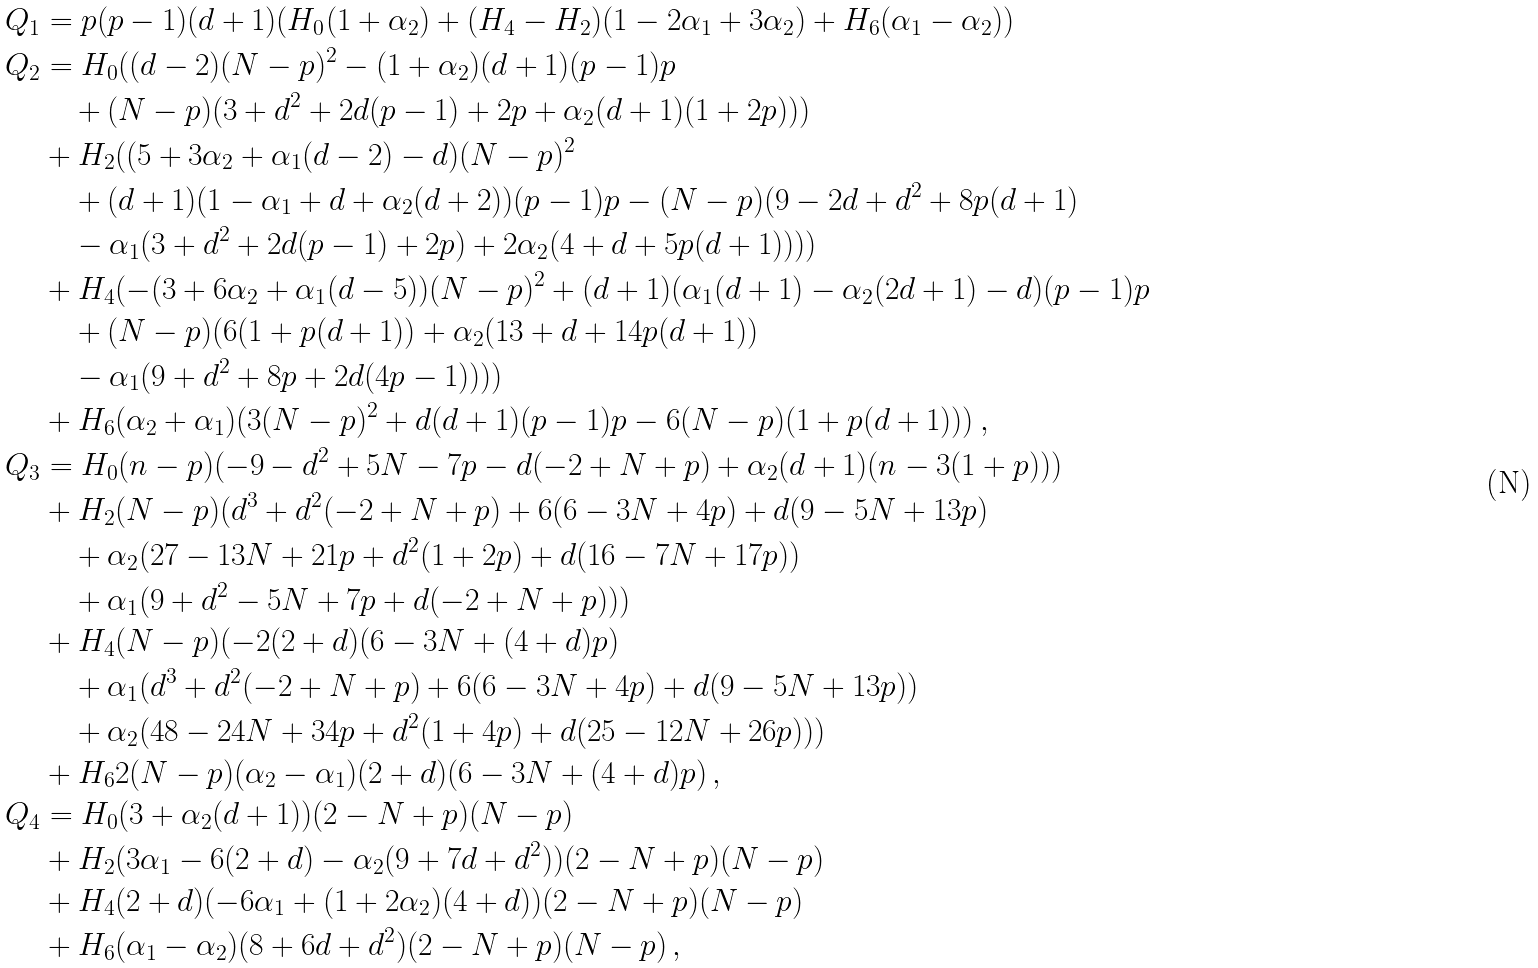<formula> <loc_0><loc_0><loc_500><loc_500>Q _ { 1 } & = p ( p - 1 ) ( d + 1 ) ( H _ { 0 } ( 1 + \alpha _ { 2 } ) + ( H _ { 4 } - H _ { 2 } ) ( 1 - 2 \alpha _ { 1 } + 3 \alpha _ { 2 } ) + H _ { 6 } ( \alpha _ { 1 } - \alpha _ { 2 } ) ) \, \\ Q _ { 2 } & = H _ { 0 } ( ( d - 2 ) ( N - p ) ^ { 2 } - ( 1 + \alpha _ { 2 } ) ( d + 1 ) ( p - 1 ) p \\ & \quad + ( N - p ) ( 3 + d ^ { 2 } + 2 d ( p - 1 ) + 2 p + \alpha _ { 2 } ( d + 1 ) ( 1 + 2 p ) ) ) \\ & + H _ { 2 } ( ( 5 + 3 \alpha _ { 2 } + \alpha _ { 1 } ( d - 2 ) - d ) ( N - p ) ^ { 2 } \\ & \quad + ( d + 1 ) ( 1 - \alpha _ { 1 } + d + \alpha _ { 2 } ( d + 2 ) ) ( p - 1 ) p - ( N - p ) ( 9 - 2 d + d ^ { 2 } + 8 p ( d + 1 ) \\ & \quad - \alpha _ { 1 } ( 3 + d ^ { 2 } + 2 d ( p - 1 ) + 2 p ) + 2 \alpha _ { 2 } ( 4 + d + 5 p ( d + 1 ) ) ) ) \\ & + H _ { 4 } ( - ( 3 + 6 \alpha _ { 2 } + \alpha _ { 1 } ( d - 5 ) ) ( N - p ) ^ { 2 } + ( d + 1 ) ( \alpha _ { 1 } ( d + 1 ) - \alpha _ { 2 } ( 2 d + 1 ) - d ) ( p - 1 ) p \\ & \quad + ( N - p ) ( 6 ( 1 + p ( d + 1 ) ) + \alpha _ { 2 } ( 1 3 + d + 1 4 p ( d + 1 ) ) \\ & \quad - \alpha _ { 1 } ( 9 + d ^ { 2 } + 8 p + 2 d ( 4 p - 1 ) ) ) ) \\ & + H _ { 6 } ( \alpha _ { 2 } + \alpha _ { 1 } ) ( 3 ( N - p ) ^ { 2 } + d ( d + 1 ) ( p - 1 ) p - 6 ( N - p ) ( 1 + p ( d + 1 ) ) ) \, , \\ Q _ { 3 } & = H _ { 0 } ( n - p ) ( - 9 - d ^ { 2 } + 5 N - 7 p - d ( - 2 + N + p ) + \alpha _ { 2 } ( d + 1 ) ( n - 3 ( 1 + p ) ) ) \\ & + H _ { 2 } ( N - p ) ( d ^ { 3 } + d ^ { 2 } ( - 2 + N + p ) + 6 ( 6 - 3 N + 4 p ) + d ( 9 - 5 N + 1 3 p ) \\ & \quad + \alpha _ { 2 } ( 2 7 - 1 3 N + 2 1 p + d ^ { 2 } ( 1 + 2 p ) + d ( 1 6 - 7 N + 1 7 p ) ) \\ & \quad + \alpha _ { 1 } ( 9 + d ^ { 2 } - 5 N + 7 p + d ( - 2 + N + p ) ) ) \\ & + H _ { 4 } ( N - p ) ( - 2 ( 2 + d ) ( 6 - 3 N + ( 4 + d ) p ) \\ & \quad + \alpha _ { 1 } ( d ^ { 3 } + d ^ { 2 } ( - 2 + N + p ) + 6 ( 6 - 3 N + 4 p ) + d ( 9 - 5 N + 1 3 p ) ) \\ & \quad + \alpha _ { 2 } ( 4 8 - 2 4 N + 3 4 p + d ^ { 2 } ( 1 + 4 p ) + d ( 2 5 - 1 2 N + 2 6 p ) ) ) \\ & + H _ { 6 } 2 ( N - p ) ( \alpha _ { 2 } - \alpha _ { 1 } ) ( 2 + d ) ( 6 - 3 N + ( 4 + d ) p ) \, , \\ Q _ { 4 } & = H _ { 0 } ( 3 + \alpha _ { 2 } ( d + 1 ) ) ( 2 - N + p ) ( N - p ) \\ & + H _ { 2 } ( 3 \alpha _ { 1 } - 6 ( 2 + d ) - \alpha _ { 2 } ( 9 + 7 d + d ^ { 2 } ) ) ( 2 - N + p ) ( N - p ) \\ & + H _ { 4 } ( 2 + d ) ( - 6 \alpha _ { 1 } + ( 1 + 2 \alpha _ { 2 } ) ( 4 + d ) ) ( 2 - N + p ) ( N - p ) \\ & + H _ { 6 } ( \alpha _ { 1 } - \alpha _ { 2 } ) ( 8 + 6 d + d ^ { 2 } ) ( 2 - N + p ) ( N - p ) \, ,</formula> 